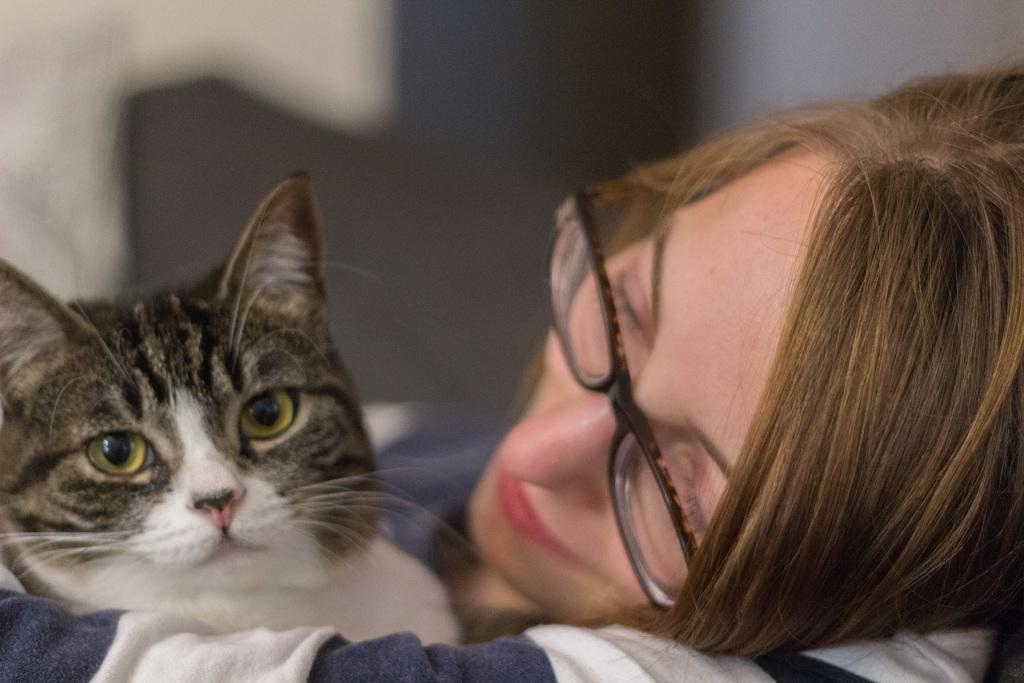Who is the main subject in the image? There is a woman in the image. What is the woman holding in the image? The woman is holding a cat. Can you describe any accessories the woman is wearing? The woman is wearing spectacles. How would you describe the background of the image? The background of the image is blurry. Are there any cobwebs visible in the image? There is no mention of cobwebs in the provided facts, and therefore it cannot be determined if any are present in the image. 